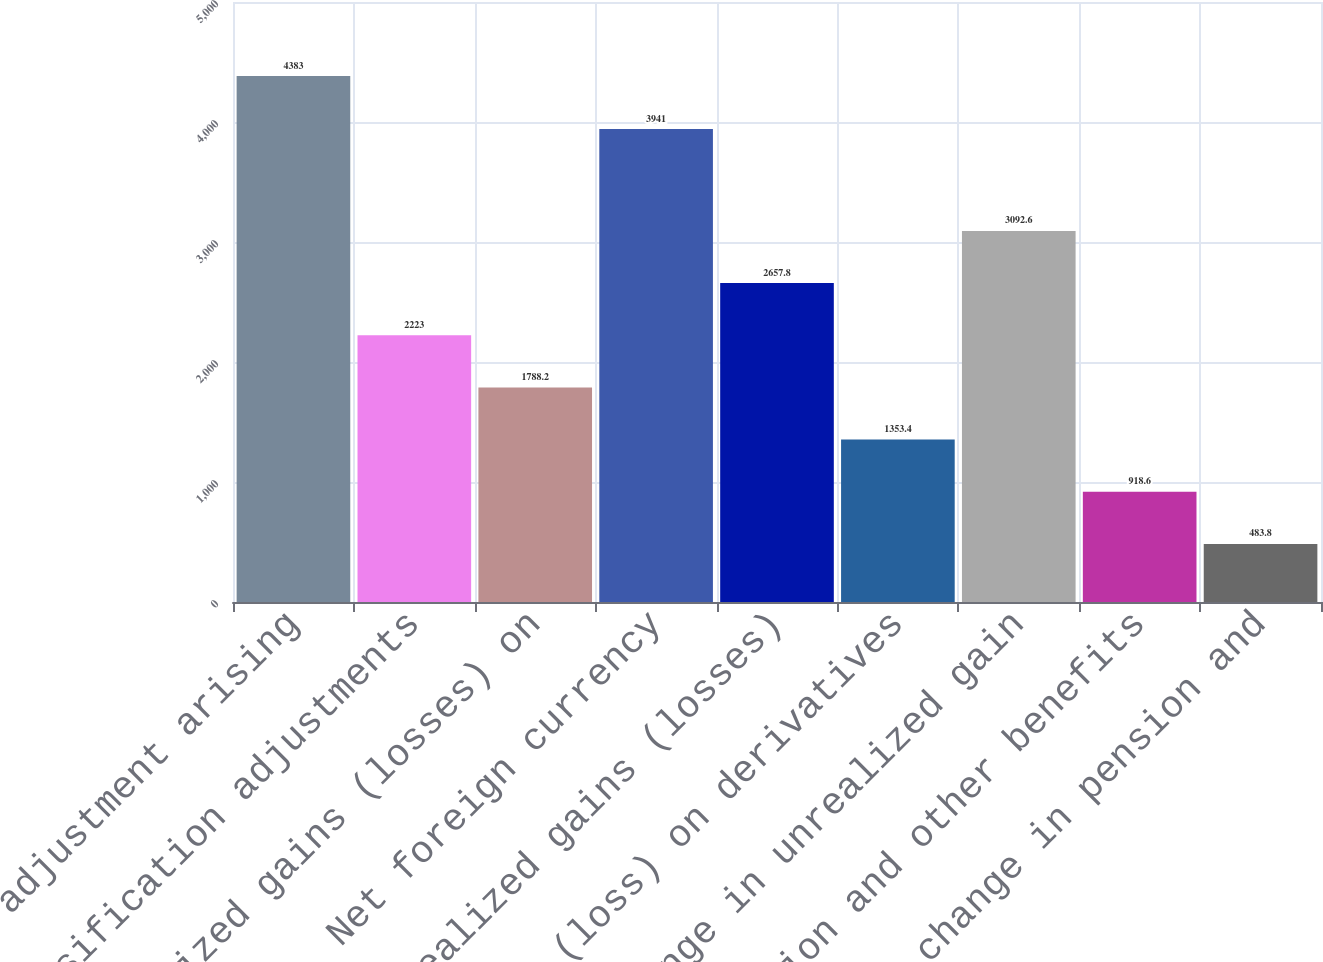<chart> <loc_0><loc_0><loc_500><loc_500><bar_chart><fcel>Translation adjustment arising<fcel>Reclassification adjustments<fcel>Unrealized gains (losses) on<fcel>Net foreign currency<fcel>Unrealized gains (losses)<fcel>Net gain (loss) on derivatives<fcel>Net change in unrealized gain<fcel>Net pension and other benefits<fcel>Net change in pension and<nl><fcel>4383<fcel>2223<fcel>1788.2<fcel>3941<fcel>2657.8<fcel>1353.4<fcel>3092.6<fcel>918.6<fcel>483.8<nl></chart> 